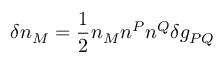Convert formula to latex. <formula><loc_0><loc_0><loc_500><loc_500>\delta n _ { M } = \frac { 1 } { 2 } n _ { M } n ^ { P } n ^ { Q } \delta g _ { P Q }</formula> 